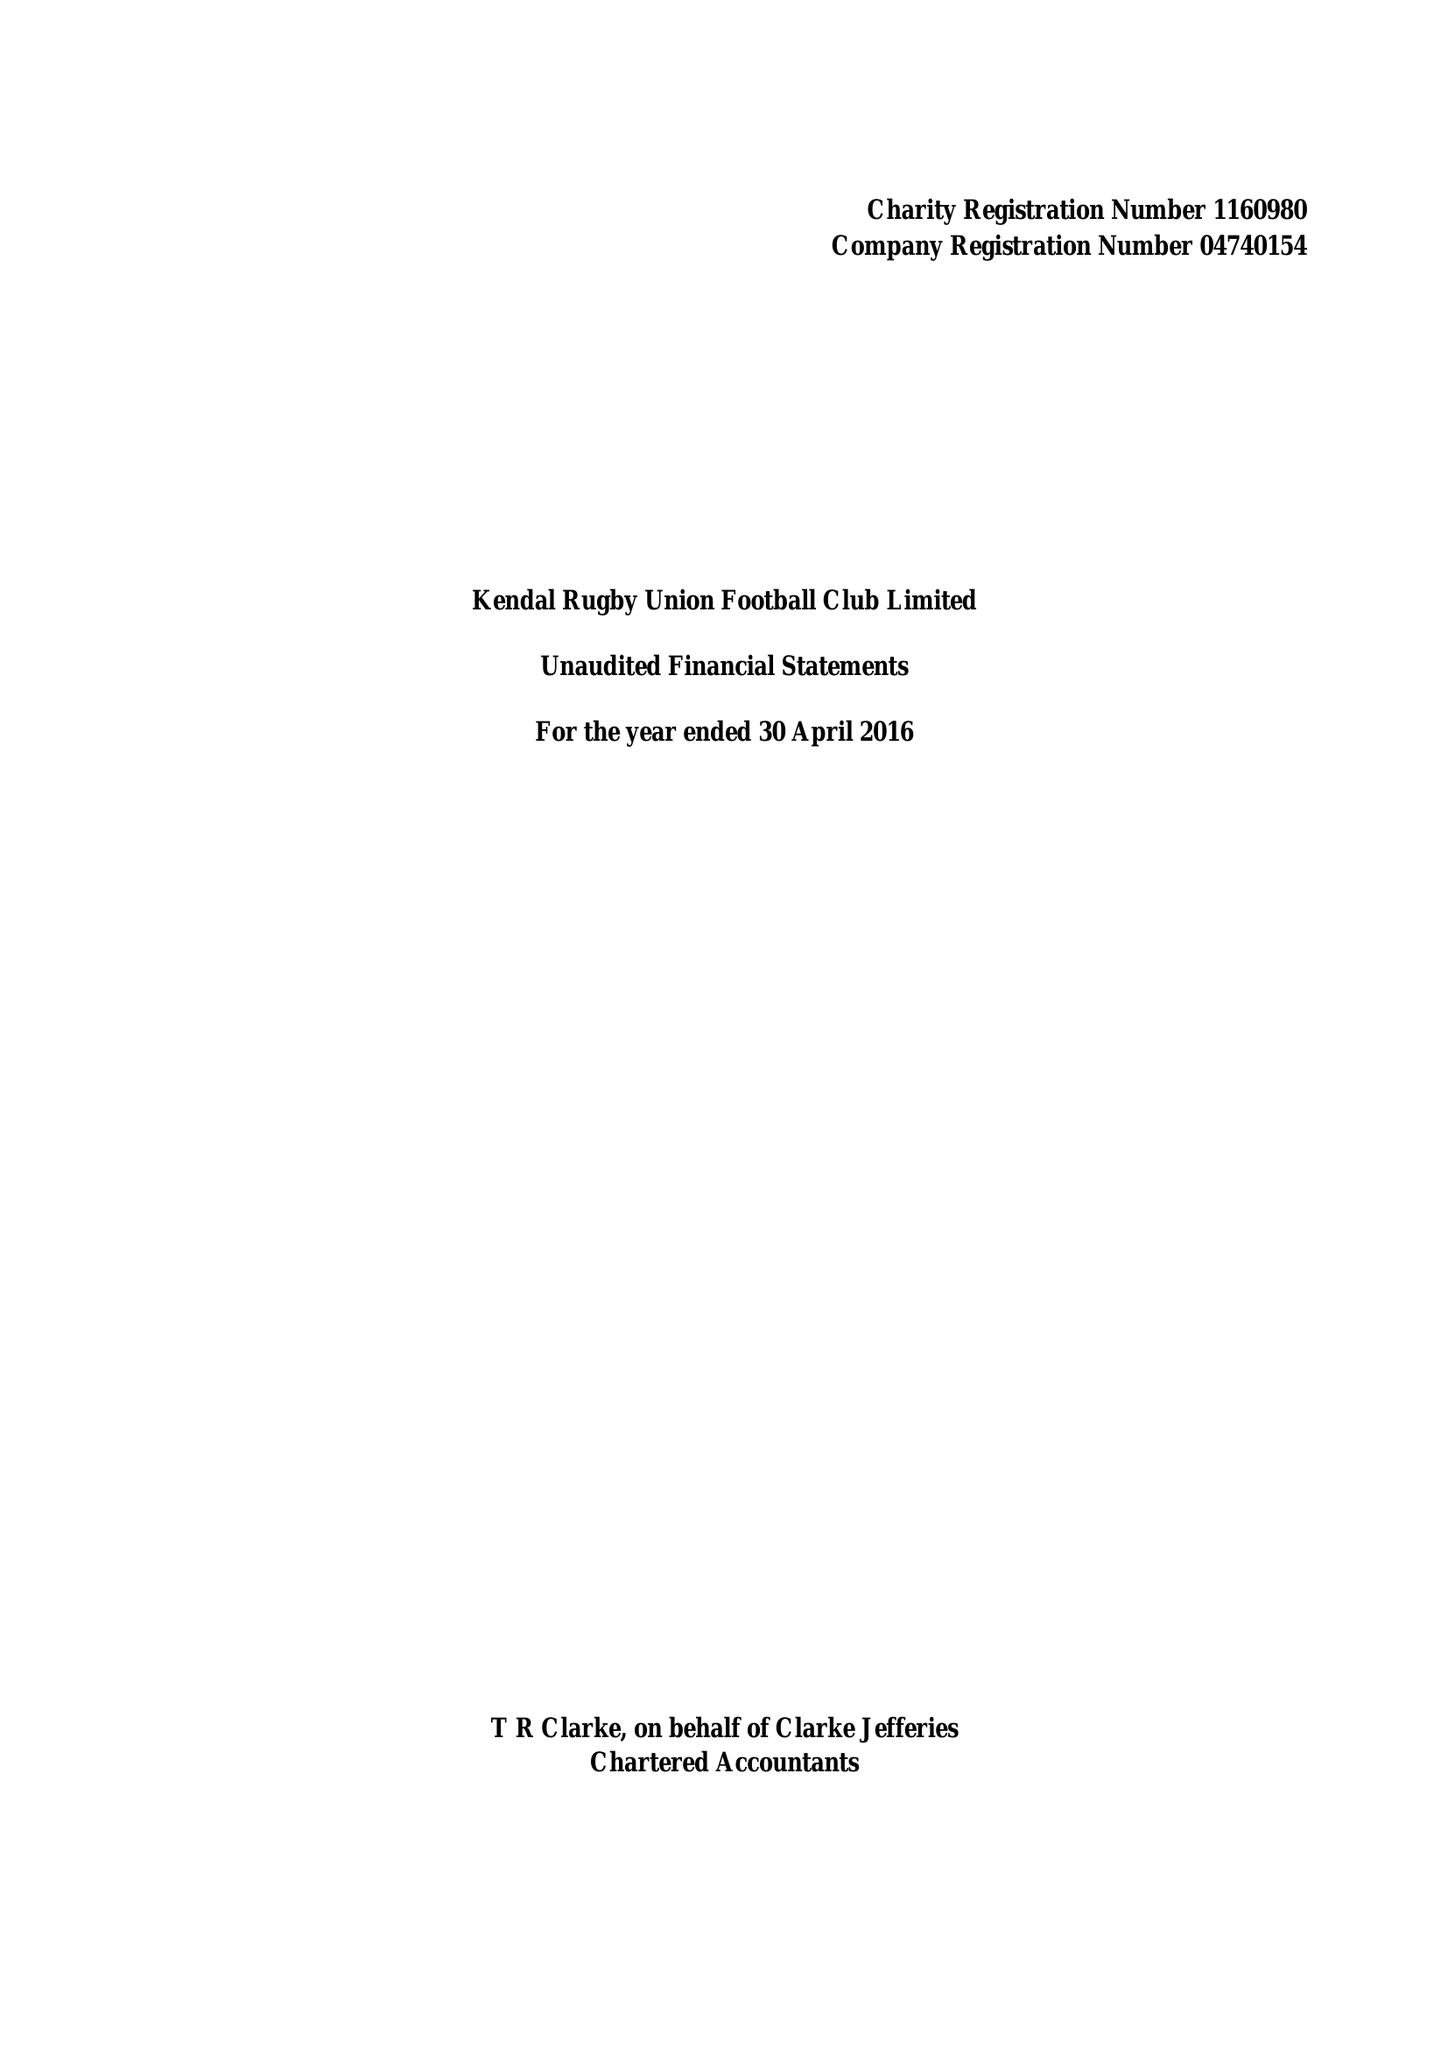What is the value for the charity_name?
Answer the question using a single word or phrase. Kendal Rugby Union Football Club Ltd. 